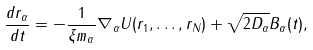Convert formula to latex. <formula><loc_0><loc_0><loc_500><loc_500>\frac { d { r } _ { \alpha } } { d t } = - \frac { 1 } { \xi m _ { \alpha } } \nabla _ { \alpha } U ( { r } _ { 1 } , \dots , { r } _ { N } ) + \sqrt { 2 D _ { \alpha } } { B } _ { \alpha } ( t ) ,</formula> 